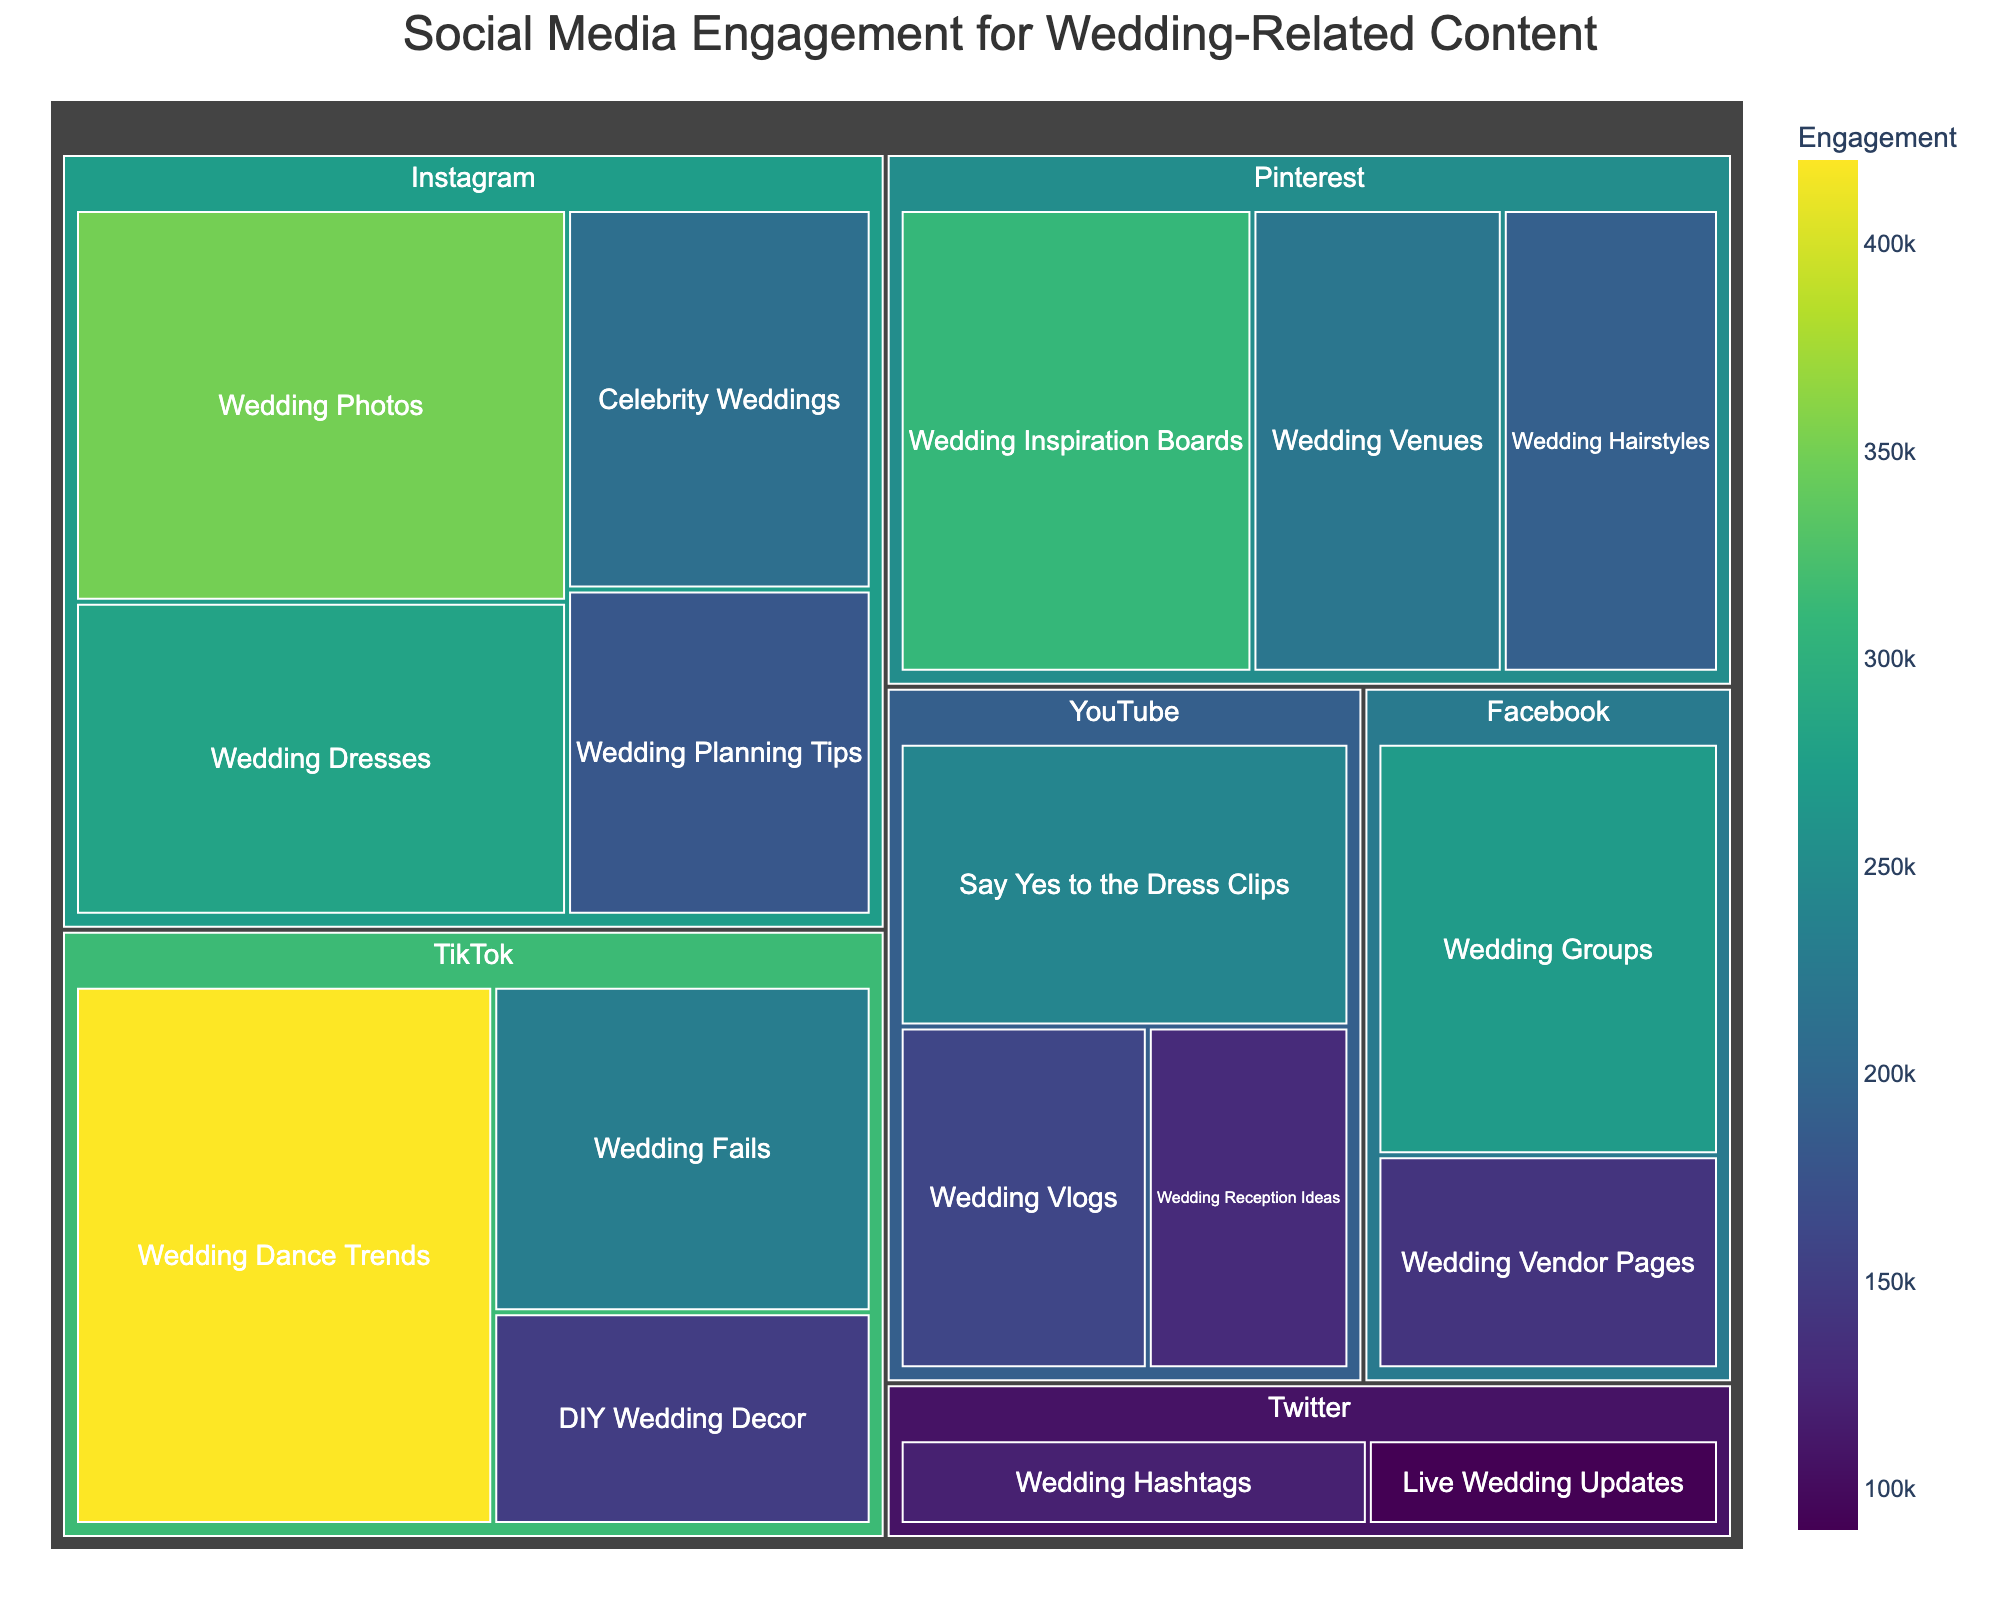What is the title of the treemap? The title of the treemap is displayed at the top of the figure.
Answer: Social Media Engagement for Wedding-Related Content Which platform has the highest engagement in wedding-related content? By looking at the treemap, the largest tile will represent the platform with the highest engagement.
Answer: TikTok What category on Instagram has the greatest engagement? Locate Instagram on the treemap and then identify the largest tile under Instagram. This tile represents the category with the greatest engagement.
Answer: Wedding Photos How much engagement does YouTube's 'Say Yes to the Dress Clips' category have? Locate YouTube on the treemap and find the 'Say Yes to the Dress Clips' tile. The engagement number should be displayed on the tile.
Answer: 240,000 Which has more engagement: Pinterest's 'Wedding Inspiration Boards' or Facebook's 'Wedding Groups'? Locate both tiles on the treemap and compare their engagement numbers.
Answer: Wedding Inspiration Boards What is the total engagement for all Instagram categories combined? Add the engagements of all categories under Instagram. Calculation: 350,000 + 180,000 + 280,000 + 210,000.
Answer: 1,020,000 Is there any category on Twitter with more than 100,000 engagement? Locate the Twitter platform on the treemap and check the engagement numbers for its categories.
Answer: Yes What's the difference in engagement between TikTok's 'Wedding Dance Trends' and YouTube's 'Wedding Reception Ideas'? Locate both tiles on the treemap and find the engagement values, then subtract one from the other. Calculation: 420,000 - 130,000.
Answer: 290,000 Which platform has the least engagement for wedding-related content? Locate the smallest tile in the treemap representing the platform with the smallest sum of engagement values.
Answer: Twitter What is the average engagement for categories under Pinterest? Add the engagement numbers for all Pinterest categories and divide by the number of categories. Calculation: (310,000 + 190,000 + 220,000) / 3.
Answer: 240,000 